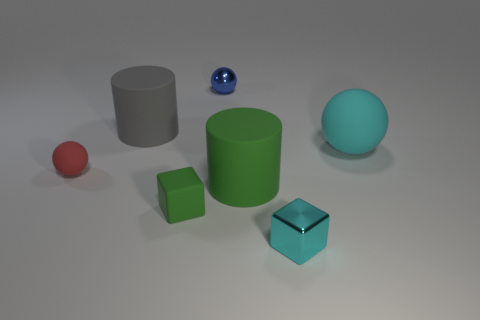Subtract all small balls. How many balls are left? 1 Subtract 2 cylinders. How many cylinders are left? 0 Add 2 small cubes. How many objects exist? 9 Subtract all green cylinders. How many cylinders are left? 1 Subtract all cylinders. How many objects are left? 5 Subtract all brown things. Subtract all large green cylinders. How many objects are left? 6 Add 1 green rubber blocks. How many green rubber blocks are left? 2 Add 6 small matte blocks. How many small matte blocks exist? 7 Subtract 0 gray spheres. How many objects are left? 7 Subtract all brown blocks. Subtract all yellow spheres. How many blocks are left? 2 